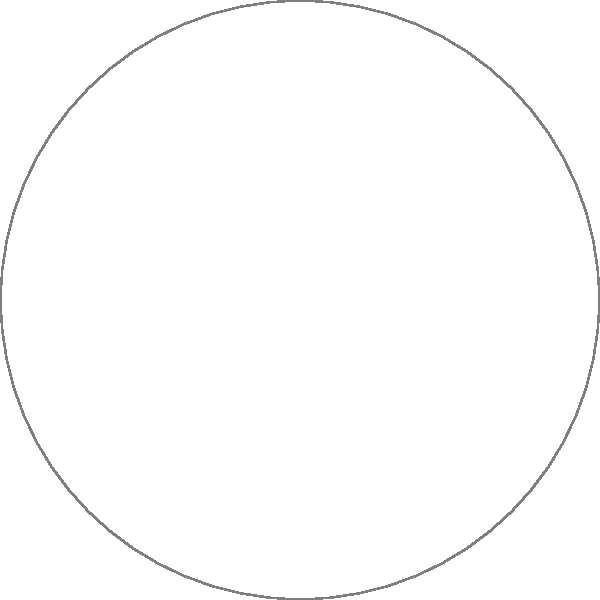In designing an accessible playground layout, you've placed five key elements as shown in the diagram: A (swing set), B (sandbox), C (slides), D (merry-go-round), and E (sensory garden). The merry-go-round (D) is considered the central hub for wheelchair users. If the distance from A to D is 15 meters, B to D is 12 meters, and C to D is 9 meters, what is the total area of the circular playground in square meters? Round your answer to the nearest whole number. To solve this problem, we'll follow these steps:

1) First, we need to determine the radius of the circular playground. We can do this using the given distances and the Pythagorean theorem.

2) Let's consider the triangle formed by A, D, and the center of the playground. If we know the radius, this would be a right-angled triangle.

3) Let $r$ be the radius of the playground and $x$ be the distance from the center to D. Then:

   $r^2 = x^2 + 15^2$ (Pythagorean theorem)

4) Similarly, for points B and C:

   $r^2 = x^2 + 12^2$
   $r^2 = x^2 + 9^2$

5) From these equations, we can deduce that:

   $15^2 - 12^2 = 3^2 = 9$
   $15^2 - 9^2 = 6^2 = 36$

6) This confirms that D is indeed at the center of the playground, and the radius is 15 meters.

7) Now that we know the radius, we can calculate the area using the formula:

   $A = \pi r^2$

8) Substituting $r = 15$:

   $A = \pi (15)^2 = 225\pi \approx 706.86$ square meters

9) Rounding to the nearest whole number, we get 707 square meters.
Answer: 707 square meters 